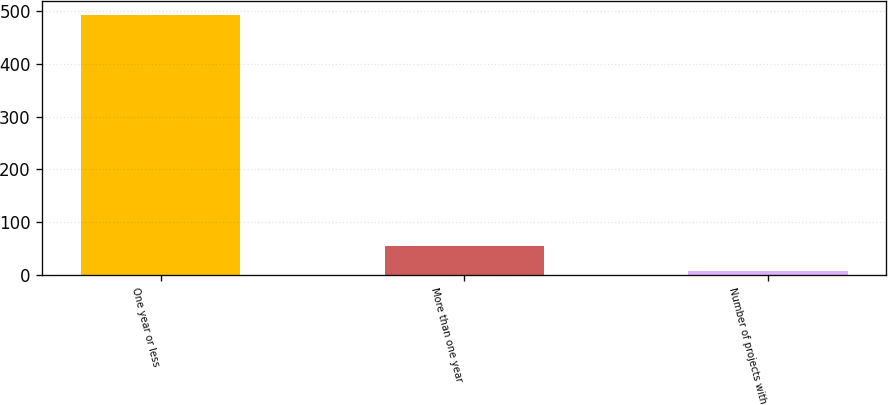<chart> <loc_0><loc_0><loc_500><loc_500><bar_chart><fcel>One year or less<fcel>More than one year<fcel>Number of projects with<nl><fcel>493<fcel>55.6<fcel>7<nl></chart> 